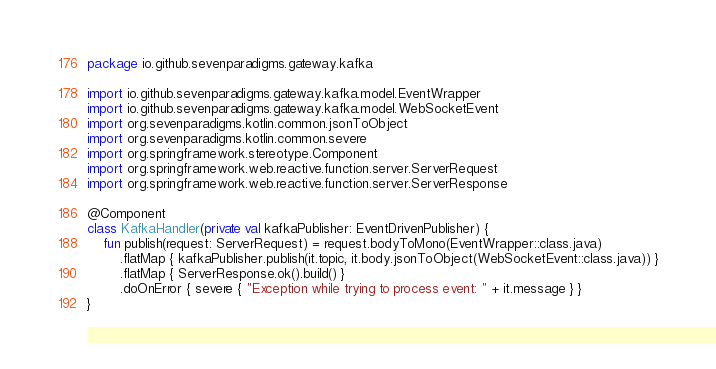<code> <loc_0><loc_0><loc_500><loc_500><_Kotlin_>package io.github.sevenparadigms.gateway.kafka

import io.github.sevenparadigms.gateway.kafka.model.EventWrapper
import io.github.sevenparadigms.gateway.kafka.model.WebSocketEvent
import org.sevenparadigms.kotlin.common.jsonToObject
import org.sevenparadigms.kotlin.common.severe
import org.springframework.stereotype.Component
import org.springframework.web.reactive.function.server.ServerRequest
import org.springframework.web.reactive.function.server.ServerResponse

@Component
class KafkaHandler(private val kafkaPublisher: EventDrivenPublisher) {
    fun publish(request: ServerRequest) = request.bodyToMono(EventWrapper::class.java)
        .flatMap { kafkaPublisher.publish(it.topic, it.body.jsonToObject(WebSocketEvent::class.java)) }
        .flatMap { ServerResponse.ok().build() }
        .doOnError { severe { "Exception while trying to process event: " + it.message } }
}
</code> 